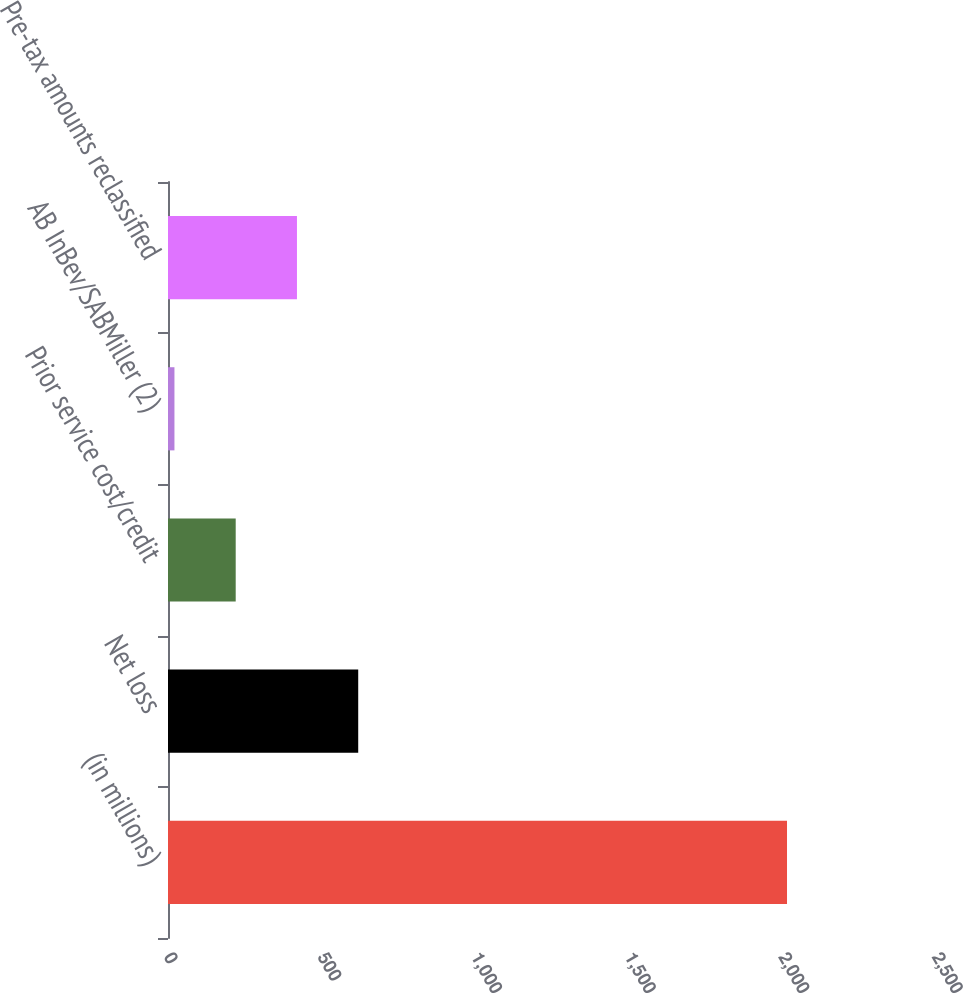Convert chart to OTSL. <chart><loc_0><loc_0><loc_500><loc_500><bar_chart><fcel>(in millions)<fcel>Net loss<fcel>Prior service cost/credit<fcel>AB InBev/SABMiller (2)<fcel>Pre-tax amounts reclassified<nl><fcel>2015<fcel>619.2<fcel>220.4<fcel>21<fcel>419.8<nl></chart> 